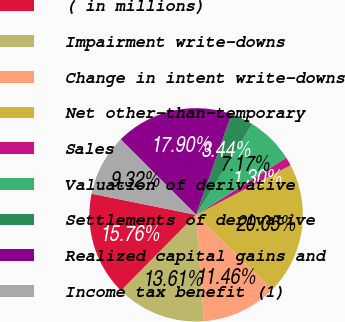<chart> <loc_0><loc_0><loc_500><loc_500><pie_chart><fcel>( in millions)<fcel>Impairment write-downs<fcel>Change in intent write-downs<fcel>Net other-than-temporary<fcel>Sales<fcel>Valuation of derivative<fcel>Settlements of derivative<fcel>Realized capital gains and<fcel>Income tax benefit (1)<nl><fcel>15.76%<fcel>13.61%<fcel>11.46%<fcel>20.05%<fcel>1.3%<fcel>7.17%<fcel>3.44%<fcel>17.9%<fcel>9.32%<nl></chart> 